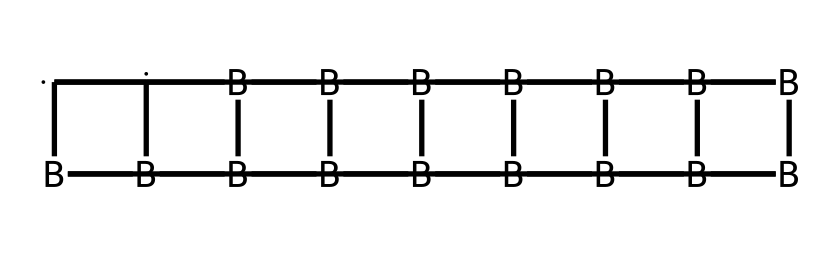What is the main element in this compound? The structure contains a significant number of boron atoms (identified by the inclusion of [B] in the SMILES), indicating that boron is the main element.
Answer: boron How many carbon atoms are present in the structure? By analyzing the SMILES representation, we can count the occurrences of carbon denoted by [C]. There are two occurrences of [C], showing that there are two carbon atoms.
Answer: 2 What is the total number of boron atoms in the compound? In the SMILES, [B] appears multiple times. Counting these occurrences gives a total of ten boron atoms in the structure.
Answer: 10 What type of structure does this compound represent? This compound represents a cage structure where the boron and carbon atoms are interconnected, forming a polyhedral geometry typical of carboranes.
Answer: cage How many rings are formed in this compound? The SMILES notation indicates bridged connections and the arrangement of atoms suggests that there are multiple interlinked cycles, leading to a total of five distinct rings in this structure.
Answer: 5 What type of bonding is primarily present in this compound? The presence of boron, which is known for forming three-coordinate systems and multi-centered bonds, suggests that the bonding mainly consists of covalent bonds through shared electrons.
Answer: covalent 